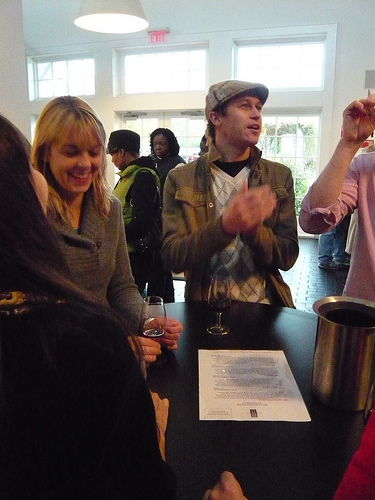<image>
Is the man on the table? No. The man is not positioned on the table. They may be near each other, but the man is not supported by or resting on top of the table. 